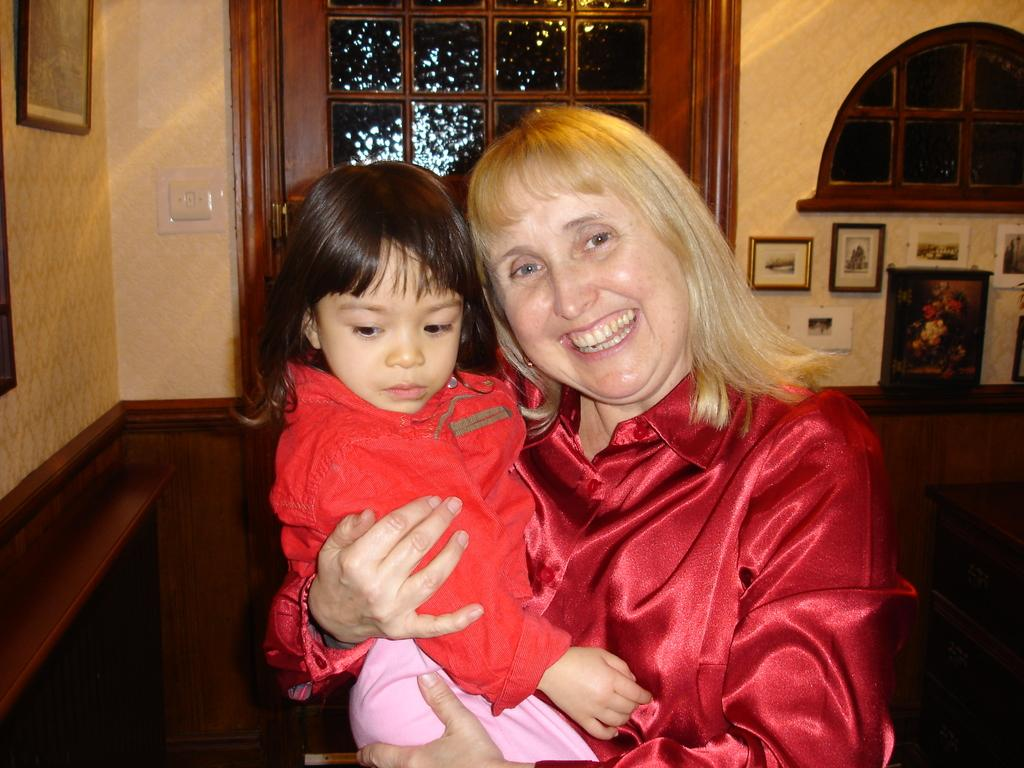Who or what can be seen in the image? There are people in the image. What architectural features are present in the image? There is a door and a window in the image. What decorative items are visible in the image? There are photo frames in the image. What functional items can be seen in the image? There are switches in the image. What type of church can be seen in the image? There is no church present in the image. How many bees are visible in the image? There are no bees present in the image. 